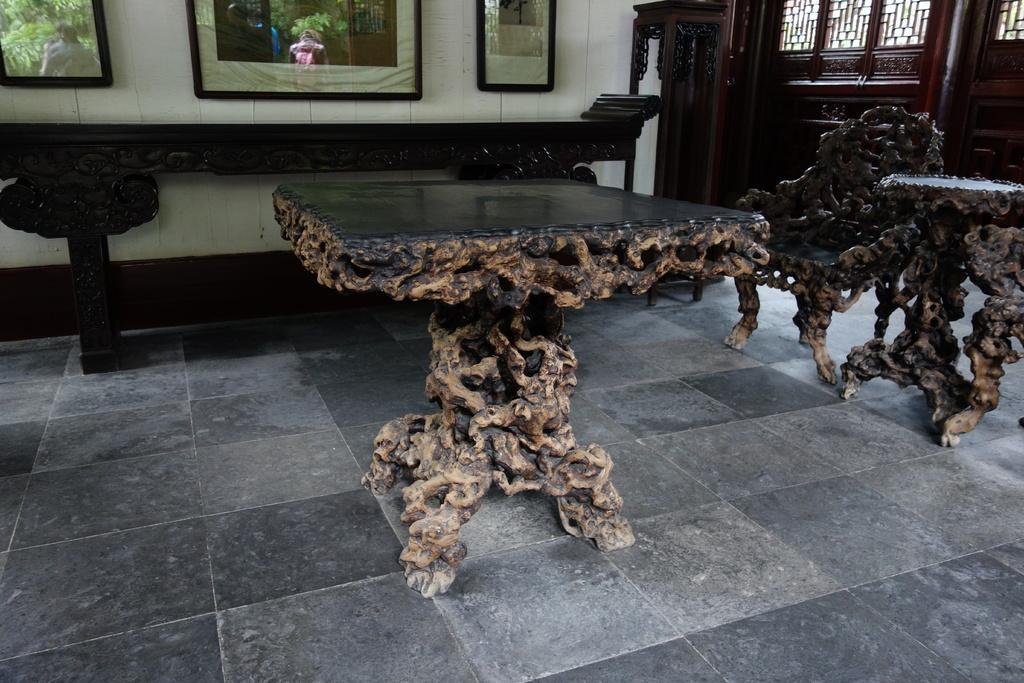Please provide a concise description of this image. In this picture I can see few tables and a chair and I can see few photo frames, I can see reflection of few people standing on the photo frames. 